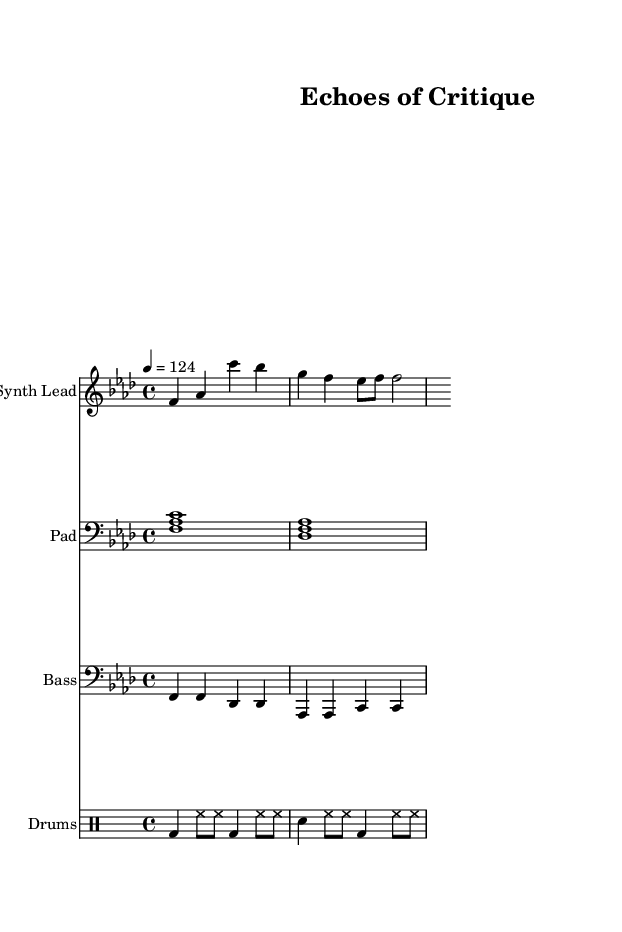What is the key signature of this music? The key signature is indicated by the sharp or flat signs at the beginning of the staff. In this piece, the two flats (B flat and E flat) are present, indicating it is in F minor.
Answer: F minor What is the time signature of this piece? The time signature is found right after the key signature at the beginning of the score. Here, it is 4/4, which means there are four beats in each measure.
Answer: 4/4 What is the tempo marking for this music? The tempo is notated at the beginning of the piece, indicating the speed at which it should be played. In this case, it reads "4 = 124," meaning there should be 124 beats per minute.
Answer: 124 How many measures are there in the synthesized lead? By counting the bars in the synth lead staff, we find that there are four measures in total, each separated by vertical bar lines.
Answer: 4 What types of instruments are present in the score? The instruments are specified at the start of each staff. We have four staves for the Synth Lead, Pad, Bass, and Drums, indicating a rich sound palette typical for deep house music.
Answer: Synth Lead, Pad, Bass, Drums How does the bass rhythm relate to the overall groove of the track? The bass rhythm consists of steady quarter notes, which help to establish a solid groove that is characteristic of deep house music. This steady rhythm contrasts the syncopated hi-hats typically found in such tracks.
Answer: Steady quarter notes 